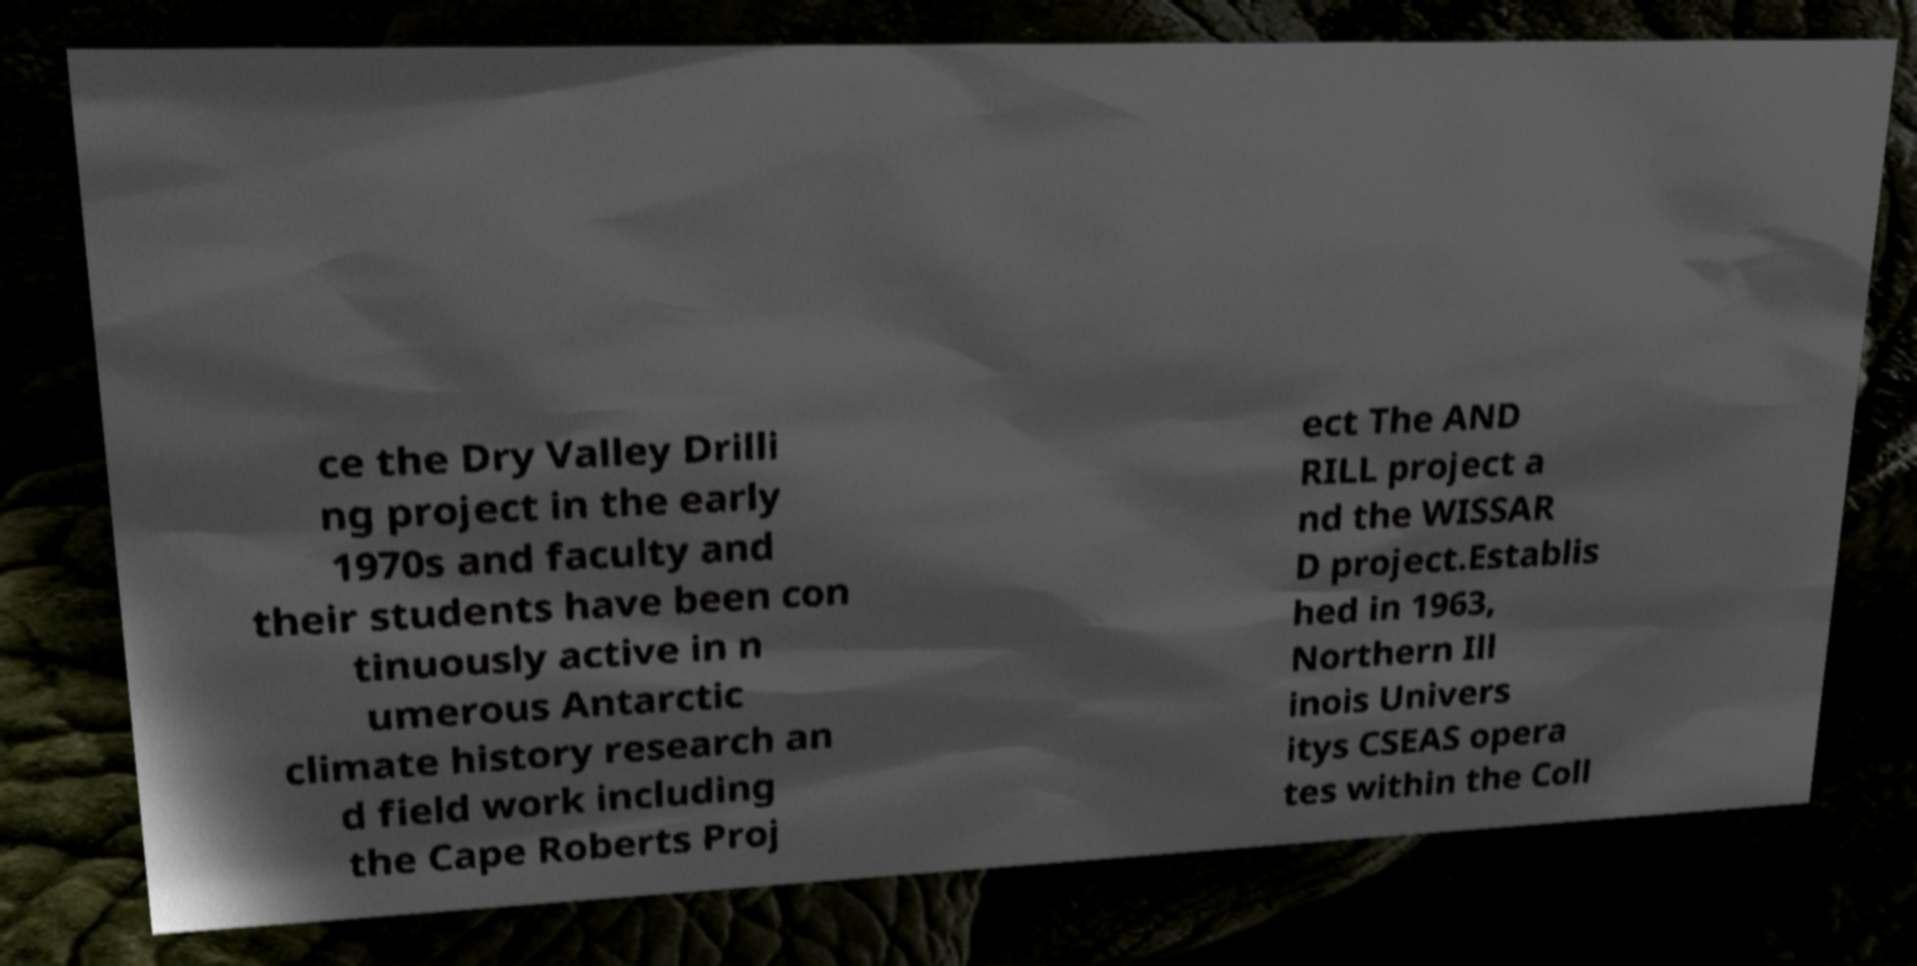For documentation purposes, I need the text within this image transcribed. Could you provide that? ce the Dry Valley Drilli ng project in the early 1970s and faculty and their students have been con tinuously active in n umerous Antarctic climate history research an d field work including the Cape Roberts Proj ect The AND RILL project a nd the WISSAR D project.Establis hed in 1963, Northern Ill inois Univers itys CSEAS opera tes within the Coll 